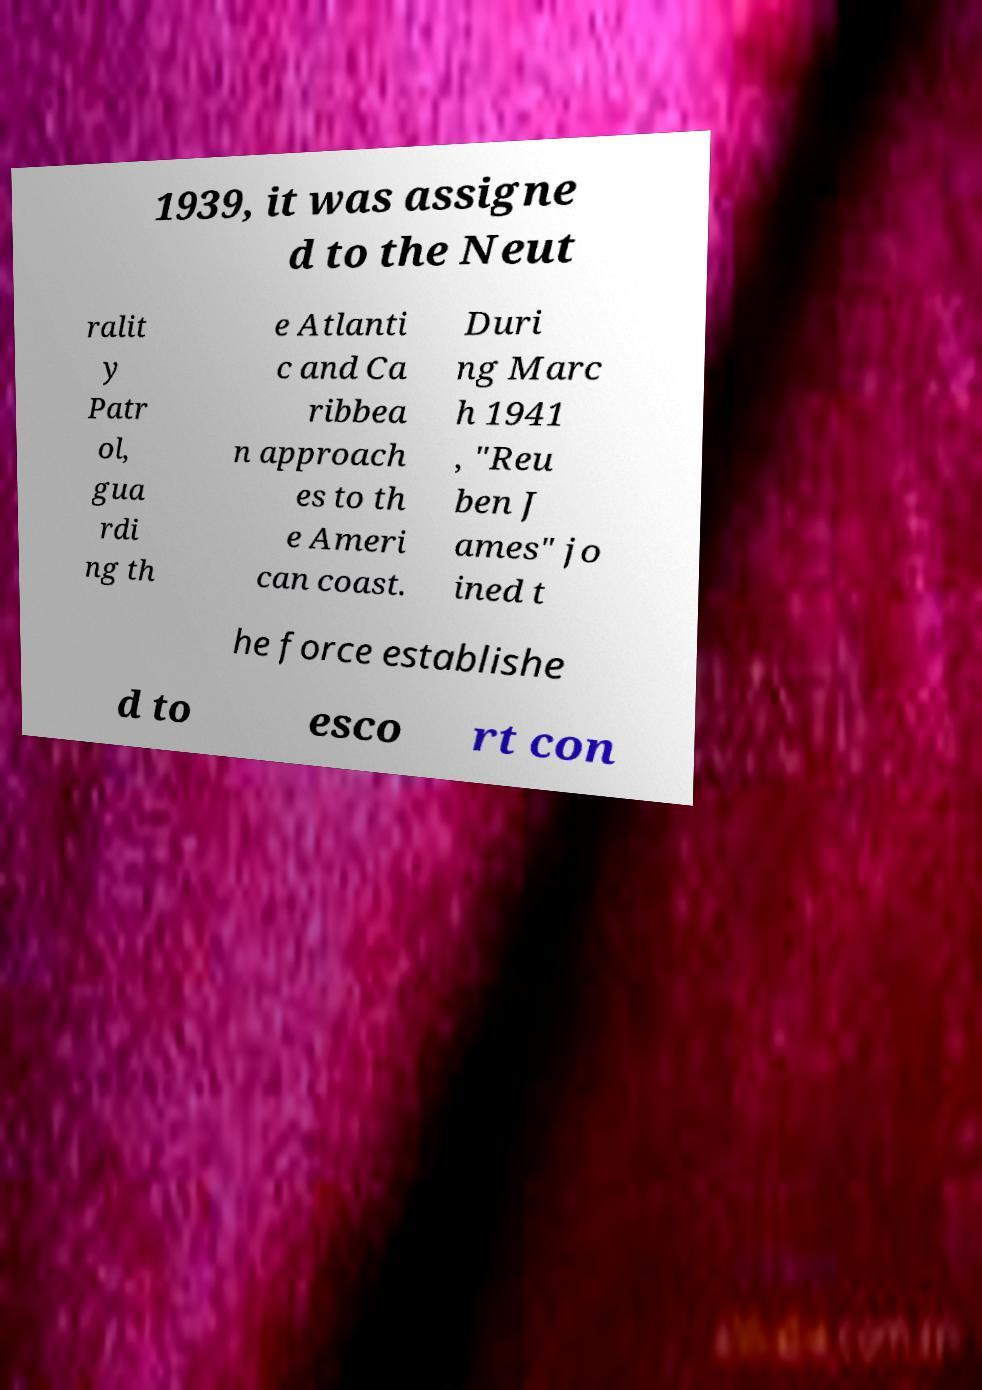Can you accurately transcribe the text from the provided image for me? 1939, it was assigne d to the Neut ralit y Patr ol, gua rdi ng th e Atlanti c and Ca ribbea n approach es to th e Ameri can coast. Duri ng Marc h 1941 , "Reu ben J ames" jo ined t he force establishe d to esco rt con 